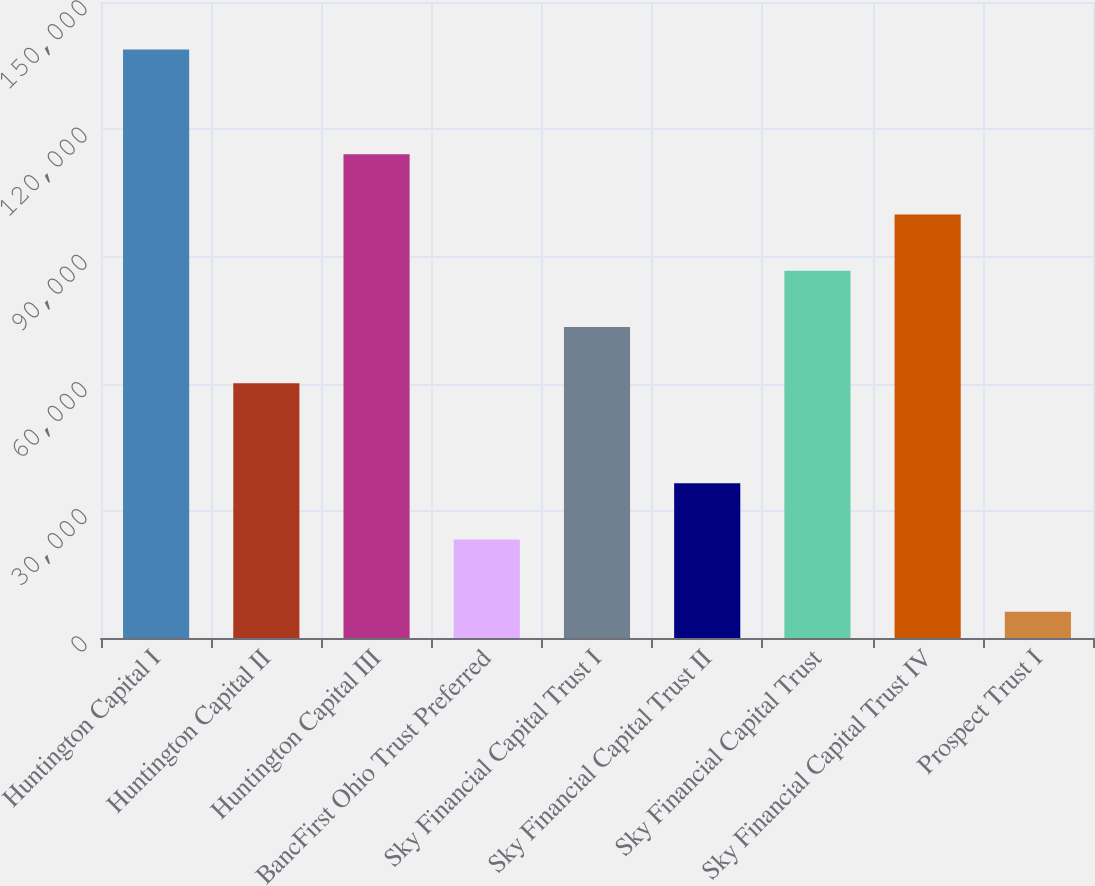<chart> <loc_0><loc_0><loc_500><loc_500><bar_chart><fcel>Huntington Capital I<fcel>Huntington Capital II<fcel>Huntington Capital III<fcel>BancFirst Ohio Trust Preferred<fcel>Sky Financial Capital Trust I<fcel>Sky Financial Capital Trust II<fcel>Sky Financial Capital Trust<fcel>Sky Financial Capital Trust IV<fcel>Prospect Trust I<nl><fcel>138816<fcel>60093<fcel>114072<fcel>23248<fcel>73356<fcel>36511<fcel>86619<fcel>99882<fcel>6186<nl></chart> 